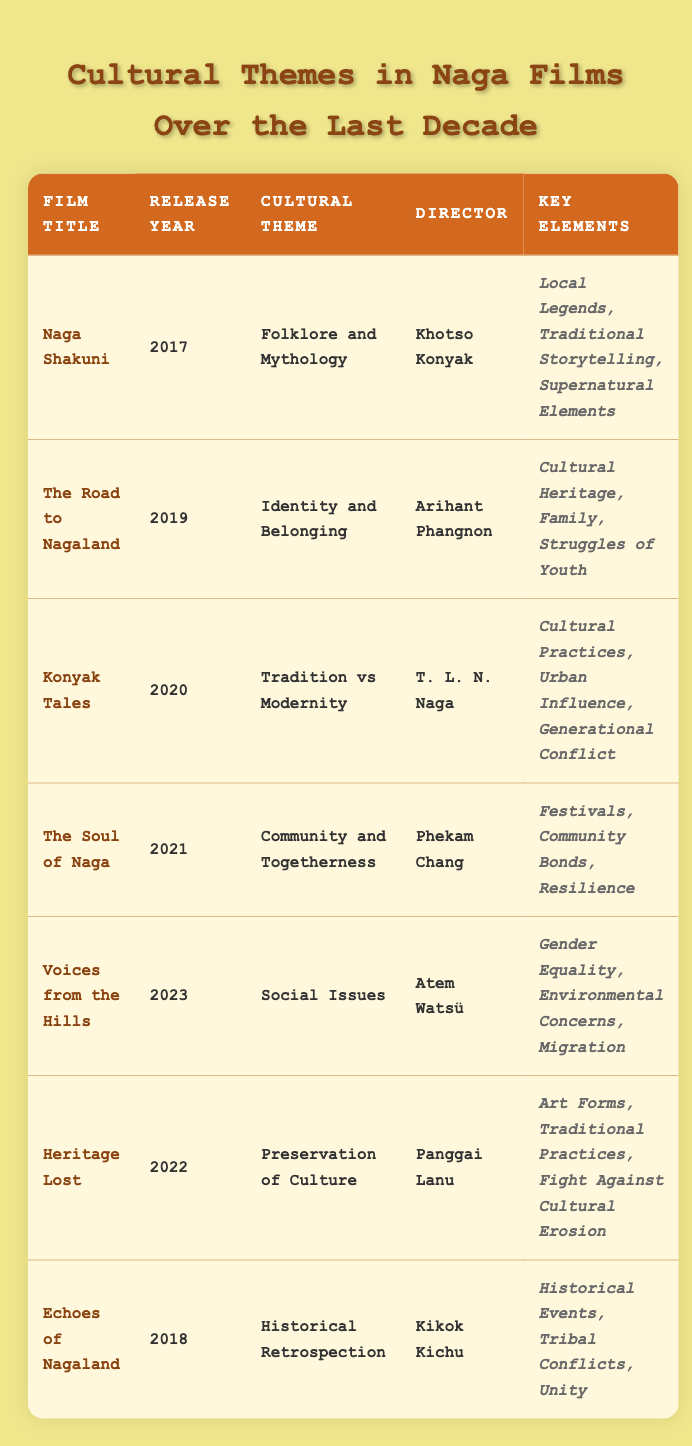What is the cultural theme of "Konyak Tales"? By looking at the entry for "Konyak Tales," we see that its cultural theme is listed as "Tradition vs Modernity."
Answer: Tradition vs Modernity Which film was directed by Khotso Konyak? Referring to the table, "Naga Shakuni" is the film directed by Khotso Konyak, as indicated in the respective row.
Answer: Naga Shakuni What year was "Voices from the Hills" released? The row for "Voices from the Hills" shows that it was released in the year 2023.
Answer: 2023 How many films focus on social issues? "Voices from the Hills" is the only film with the cultural theme focused on social issues, as there is only one entry in that category.
Answer: 1 Which film explores the theme of preservation of culture? The table shows that "Heritage Lost" is the film that addresses the preservation of culture as its central theme.
Answer: Heritage Lost Is there a film that depicts folklore and mythology? Yes, the table indicates "Naga Shakuni" explicitly deals with the theme of folklore and mythology.
Answer: Yes What is the key element associated with "The Soul of Naga"? The entry for "The Soul of Naga" lists key elements as "Festivals, Community Bonds, Resilience."
Answer: Festivals, Community Bonds, Resilience What is the difference in release years between "The Road to Nagaland" and "Konyak Tales"? "The Road to Nagaland" was released in 2019, and "Konyak Tales" in 2020. The difference is 2020 - 2019 = 1 year.
Answer: 1 year Who directed the film "Echoes of Nagaland"? The table states that "Echoes of Nagaland" was directed by Kikok Kichu.
Answer: Kikok Kichu Which film was released first: "Heritage Lost" or "The Soul of Naga"? Comparing the release years—"Heritage Lost" was released in 2022, and "The Soul of Naga" was released in 2021. Therefore, "The Soul of Naga" was released first.
Answer: The Soul of Naga What are the key elements in "Voices from the Hills"? The row for "Voices from the Hills" lists its key elements as "Gender Equality, Environmental Concerns, Migration."
Answer: Gender Equality, Environmental Concerns, Migration Which cultural theme has the most films represented in this table? The table contains several distinct themes, but "Folklore and Mythology," "Identity and Belonging," "Tradition vs Modernity," "Community and Togetherness," "Social Issues," "Preservation of Culture," and "Historical Retrospection" each only have one film represented. Thus, none dominate.
Answer: None dominate 